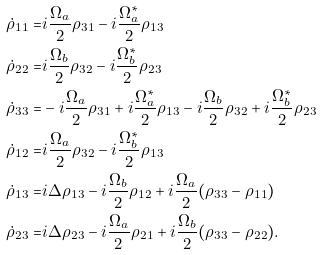<formula> <loc_0><loc_0><loc_500><loc_500>\dot { \rho } _ { 1 1 } = & i \frac { \Omega _ { a } } { 2 } \rho _ { 3 1 } - i \frac { \Omega _ { a } ^ { * } } { 2 } \rho _ { 1 3 } \\ \dot { \rho } _ { 2 2 } = & i \frac { \Omega _ { b } } { 2 } \rho _ { 3 2 } - i \frac { \Omega _ { b } ^ { * } } { 2 } \rho _ { 2 3 } \\ \dot { \rho } _ { 3 3 } = & - i \frac { \Omega _ { a } } { 2 } \rho _ { 3 1 } + i \frac { \Omega _ { a } ^ { * } } { 2 } \rho _ { 1 3 } - i \frac { \Omega _ { b } } { 2 } \rho _ { 3 2 } + i \frac { \Omega _ { b } ^ { * } } { 2 } \rho _ { 2 3 } \\ \dot { \rho } _ { 1 2 } = & i \frac { \Omega _ { a } } { 2 } \rho _ { 3 2 } - i \frac { \Omega _ { b } ^ { * } } { 2 } \rho _ { 1 3 } \\ \dot { \rho } _ { 1 3 } = & i \Delta \rho _ { 1 3 } - i \frac { \Omega _ { b } } { 2 } \rho _ { 1 2 } + i \frac { \Omega _ { a } } { 2 } ( \rho _ { 3 3 } - \rho _ { 1 1 } ) \\ \dot { \rho } _ { 2 3 } = & i \Delta \rho _ { 2 3 } - i \frac { \Omega _ { a } } { 2 } \rho _ { 2 1 } + i \frac { \Omega _ { b } } { 2 } ( \rho _ { 3 3 } - \rho _ { 2 2 } ) .</formula> 